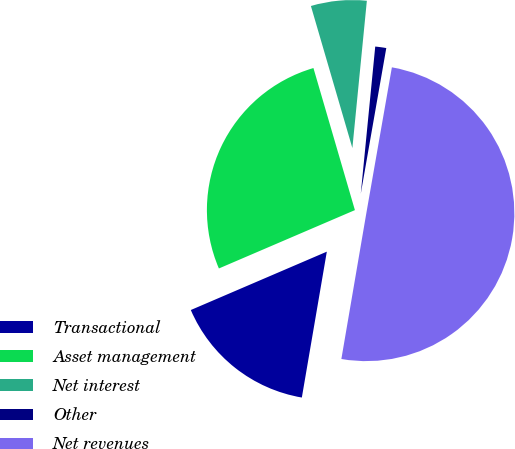Convert chart to OTSL. <chart><loc_0><loc_0><loc_500><loc_500><pie_chart><fcel>Transactional<fcel>Asset management<fcel>Net interest<fcel>Other<fcel>Net revenues<nl><fcel>15.85%<fcel>26.93%<fcel>6.08%<fcel>1.2%<fcel>49.94%<nl></chart> 